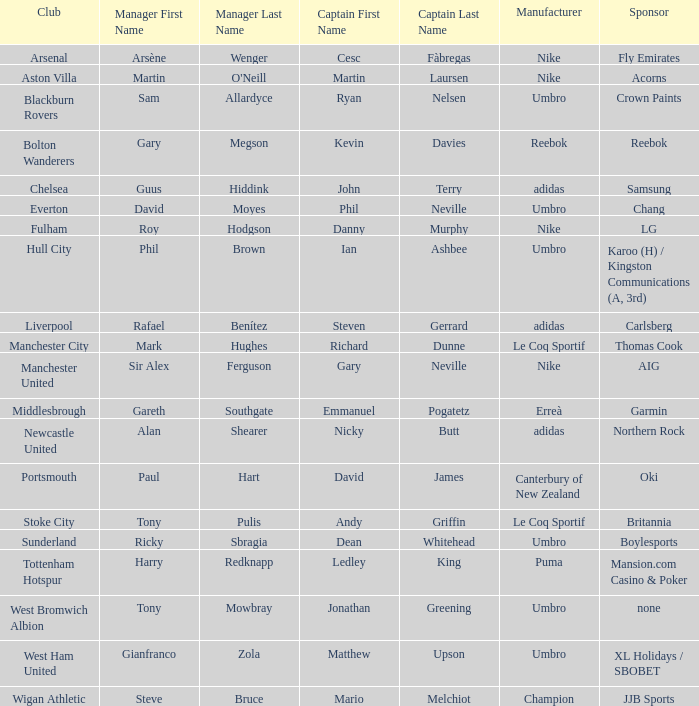In which club is Ledley King a captain? Tottenham Hotspur. 